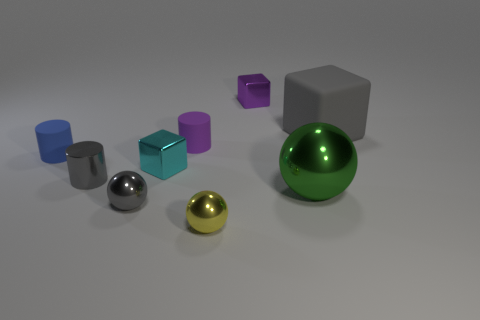Subtract all blocks. How many objects are left? 6 Add 8 big green shiny spheres. How many big green shiny spheres exist? 9 Subtract 0 brown cubes. How many objects are left? 9 Subtract all small shiny blocks. Subtract all rubber cylinders. How many objects are left? 5 Add 8 small metal blocks. How many small metal blocks are left? 10 